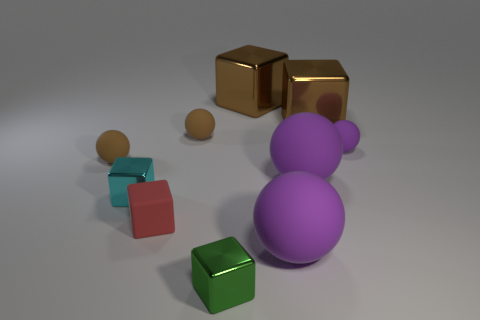What is the red cube made of?
Offer a very short reply. Rubber. Is the tiny purple object made of the same material as the tiny green object?
Give a very brief answer. No. There is another rubber cube that is the same size as the green cube; what color is it?
Your answer should be compact. Red. There is a red block; is its size the same as the brown matte ball that is behind the small purple matte object?
Provide a succinct answer. Yes. Do the cyan object and the green cube that is in front of the cyan thing have the same material?
Ensure brevity in your answer.  Yes. What material is the green object that is the same shape as the small cyan metal object?
Ensure brevity in your answer.  Metal. Are any tiny blue cubes visible?
Keep it short and to the point. No. The big thing that is both in front of the small purple ball and behind the cyan shiny thing is made of what material?
Give a very brief answer. Rubber. Is the number of brown rubber objects to the left of the small rubber block greater than the number of small cubes that are in front of the green metallic block?
Your answer should be very brief. Yes. Is there a purple matte thing that has the same size as the cyan metal object?
Keep it short and to the point. Yes. 